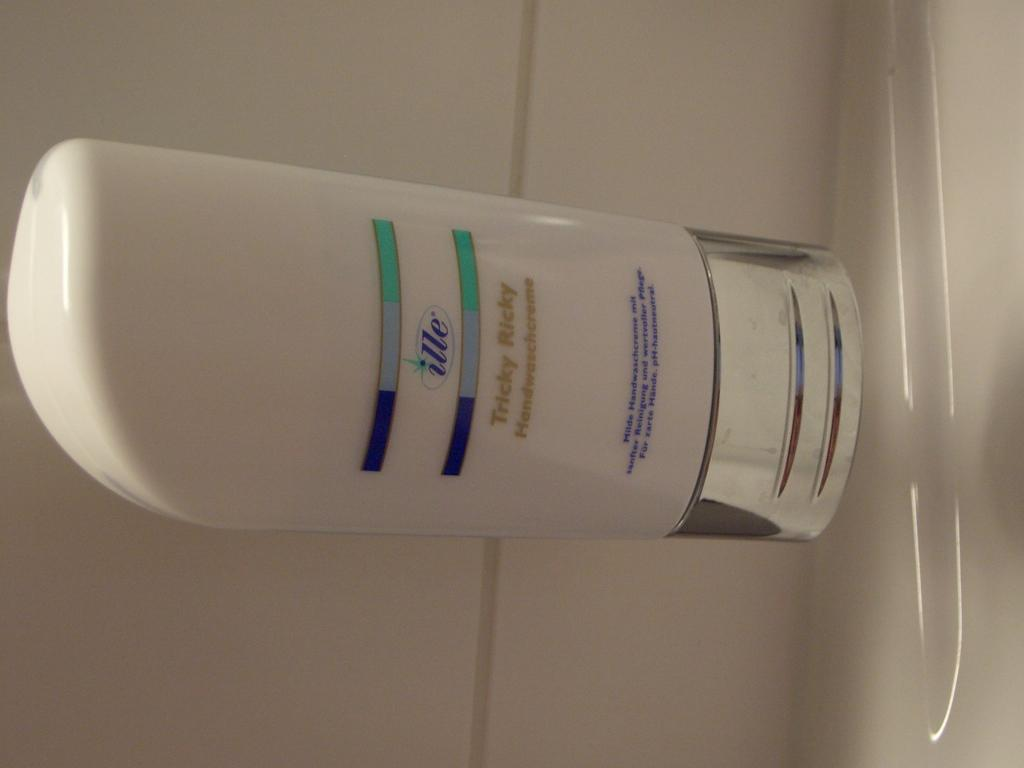<image>
Summarize the visual content of the image. A tube of beauty product from the ille brand. 